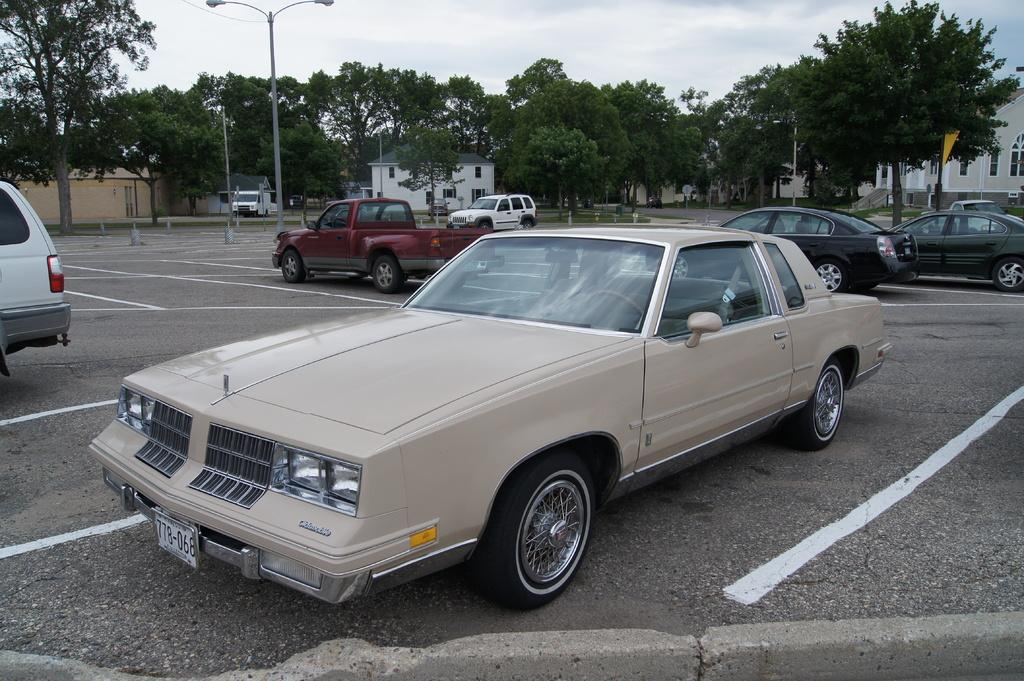What can be seen in the image in terms of vehicles? There are many cars parked in the image. What structures can be seen in the background of the image? There are houses in the background of the image. What type of objects can be seen in the background of the image? There are light poles and trees in the background of the image. What is visible in the sky in the image? The sky is visible in the background of the image, and clouds are present in the sky. What type of foot is visible on the cars in the image? There are no feet visible on the cars in the image; they are stationary vehicles. Can you see a blade being used in the image? There is no blade present in the image. 